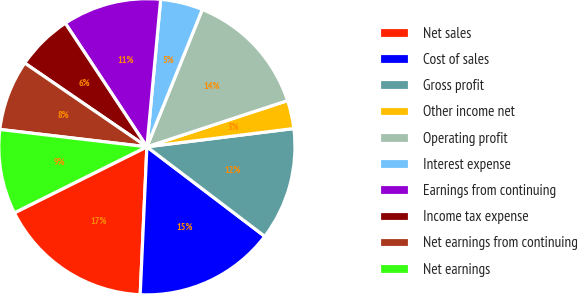Convert chart. <chart><loc_0><loc_0><loc_500><loc_500><pie_chart><fcel>Net sales<fcel>Cost of sales<fcel>Gross profit<fcel>Other income net<fcel>Operating profit<fcel>Interest expense<fcel>Earnings from continuing<fcel>Income tax expense<fcel>Net earnings from continuing<fcel>Net earnings<nl><fcel>16.92%<fcel>15.38%<fcel>12.31%<fcel>3.08%<fcel>13.85%<fcel>4.62%<fcel>10.77%<fcel>6.15%<fcel>7.69%<fcel>9.23%<nl></chart> 